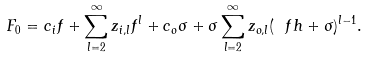<formula> <loc_0><loc_0><loc_500><loc_500>F _ { 0 } = c _ { i } f + \sum _ { l = 2 } ^ { \infty } z _ { i , l } f ^ { l } + c _ { o } \sigma + \sigma \sum _ { l = 2 } ^ { \infty } z _ { o , l } ( \ f h + \sigma ) ^ { l - 1 } .</formula> 